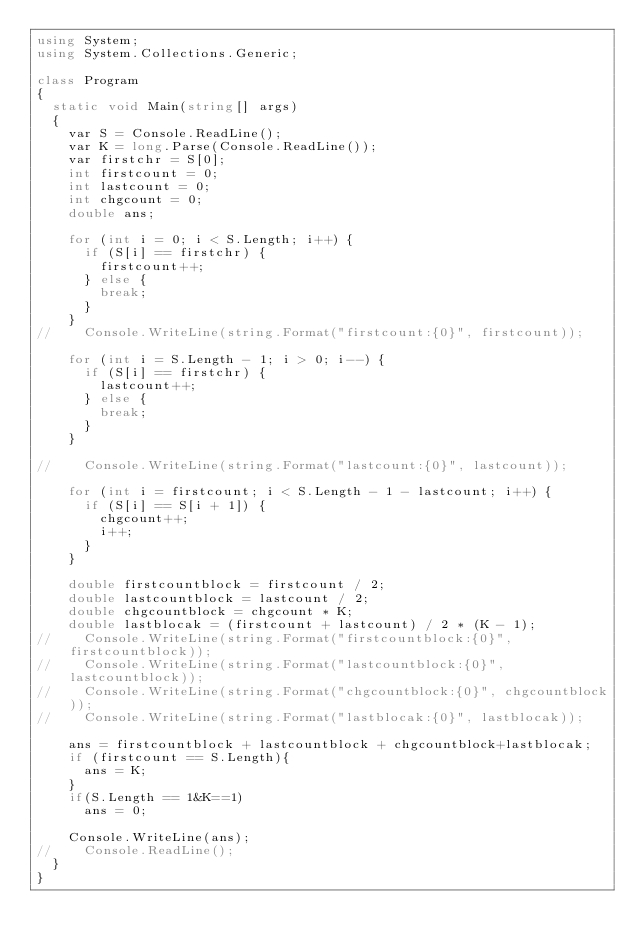<code> <loc_0><loc_0><loc_500><loc_500><_C#_>using System;
using System.Collections.Generic;

class Program
{
	static void Main(string[] args)
	{
		var S = Console.ReadLine();
		var K = long.Parse(Console.ReadLine());
		var firstchr = S[0];
		int firstcount = 0;
		int lastcount = 0;
		int chgcount = 0;
		double ans;
		
		for (int i = 0; i < S.Length; i++) {
			if (S[i] == firstchr) {
				firstcount++;
			} else {
				break;
			}
		}
//		Console.WriteLine(string.Format("firstcount:{0}", firstcount));
		
		for (int i = S.Length - 1; i > 0; i--) {
			if (S[i] == firstchr) {
				lastcount++;
			} else {
				break;
			}
		}

//		Console.WriteLine(string.Format("lastcount:{0}", lastcount));
		
		for (int i = firstcount; i < S.Length - 1 - lastcount; i++) {
			if (S[i] == S[i + 1]) {
				chgcount++;
				i++;
			}
		}
		
		double firstcountblock = firstcount / 2;
		double lastcountblock = lastcount / 2;
		double chgcountblock = chgcount * K;
		double lastblocak = (firstcount + lastcount) / 2 * (K - 1);
//		Console.WriteLine(string.Format("firstcountblock:{0}", firstcountblock));
//		Console.WriteLine(string.Format("lastcountblock:{0}", lastcountblock));
//		Console.WriteLine(string.Format("chgcountblock:{0}", chgcountblock));
//		Console.WriteLine(string.Format("lastblocak:{0}", lastblocak));
		
		ans = firstcountblock + lastcountblock + chgcountblock+lastblocak;
		if (firstcount == S.Length){
			ans = K;
		}
		if(S.Length == 1&K==1)
			ans = 0;

		Console.WriteLine(ans);
//		Console.ReadLine();
	}
}</code> 